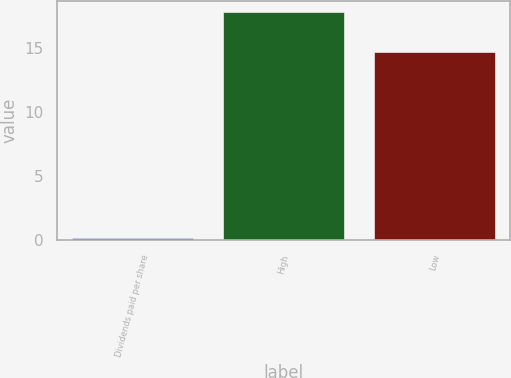Convert chart to OTSL. <chart><loc_0><loc_0><loc_500><loc_500><bar_chart><fcel>Dividends paid per share<fcel>High<fcel>Low<nl><fcel>0.15<fcel>17.75<fcel>14.68<nl></chart> 